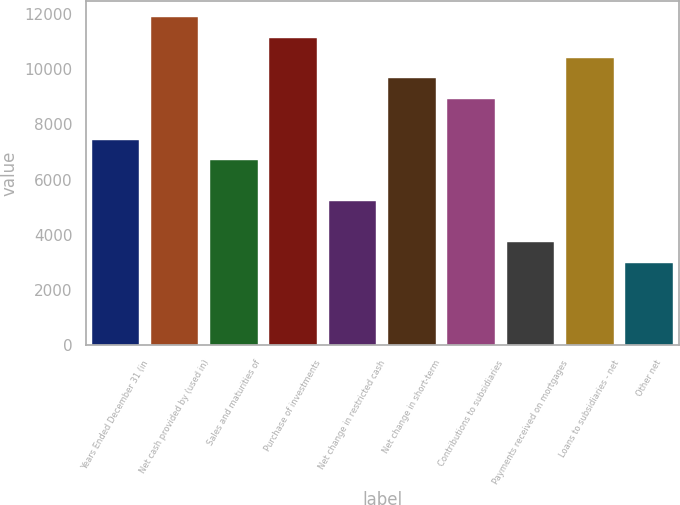Convert chart to OTSL. <chart><loc_0><loc_0><loc_500><loc_500><bar_chart><fcel>Years Ended December 31 (in<fcel>Net cash provided by (used in)<fcel>Sales and maturities of<fcel>Purchase of investments<fcel>Net change in restricted cash<fcel>Net change in short-term<fcel>Contributions to subsidiaries<fcel>Payments received on mortgages<fcel>Loans to subsidiaries - net<fcel>Other net<nl><fcel>7439<fcel>11884.4<fcel>6698.1<fcel>11143.5<fcel>5216.3<fcel>9661.7<fcel>8920.8<fcel>3734.5<fcel>10402.6<fcel>2993.6<nl></chart> 